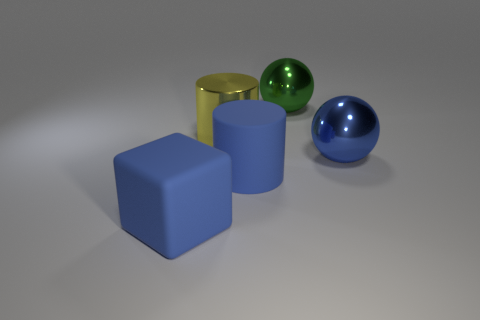Add 3 small cyan spheres. How many objects exist? 8 Subtract all cubes. How many objects are left? 4 Subtract 0 yellow spheres. How many objects are left? 5 Subtract all small red spheres. Subtract all blue spheres. How many objects are left? 4 Add 2 large blue objects. How many large blue objects are left? 5 Add 2 big green things. How many big green things exist? 3 